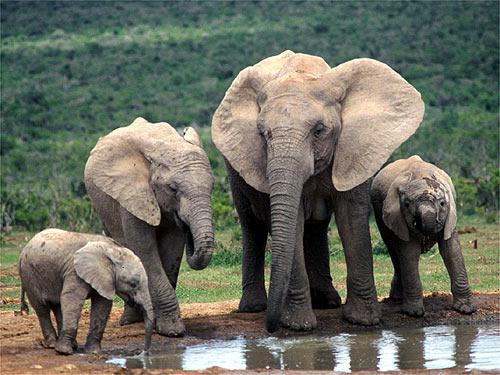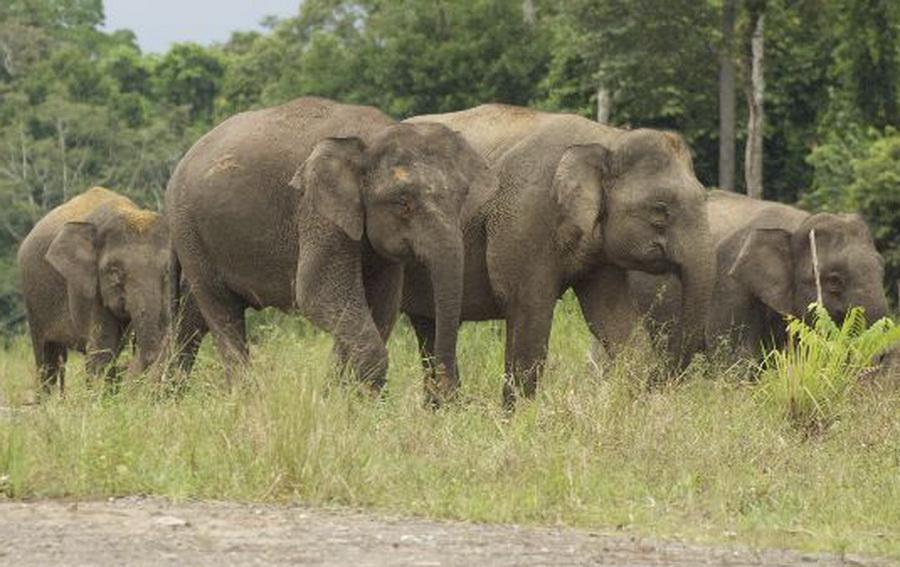The first image is the image on the left, the second image is the image on the right. Given the left and right images, does the statement "Elephants are interacting with water." hold true? Answer yes or no. Yes. 